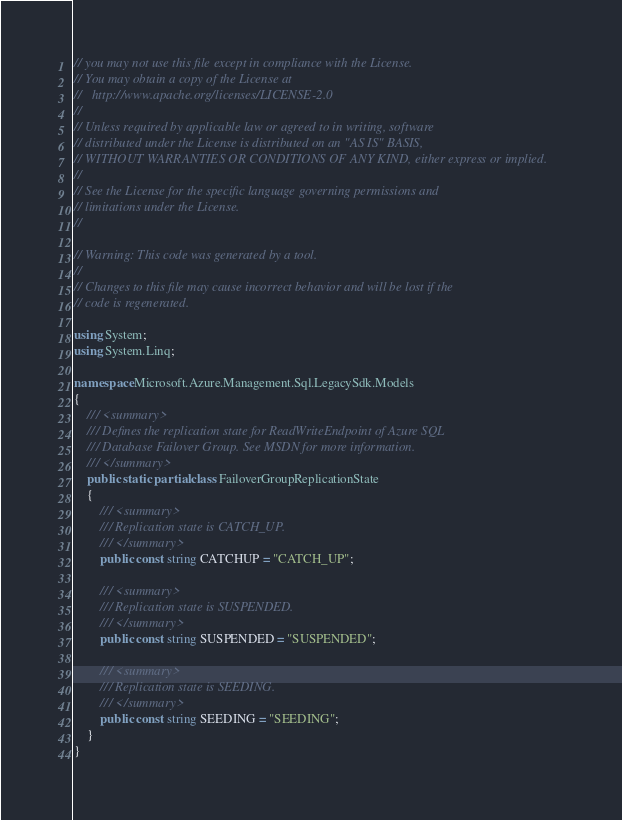<code> <loc_0><loc_0><loc_500><loc_500><_C#_>// you may not use this file except in compliance with the License.
// You may obtain a copy of the License at
//   http://www.apache.org/licenses/LICENSE-2.0
// 
// Unless required by applicable law or agreed to in writing, software
// distributed under the License is distributed on an "AS IS" BASIS,
// WITHOUT WARRANTIES OR CONDITIONS OF ANY KIND, either express or implied.
// 
// See the License for the specific language governing permissions and
// limitations under the License.
// 

// Warning: This code was generated by a tool.
// 
// Changes to this file may cause incorrect behavior and will be lost if the
// code is regenerated.

using System;
using System.Linq;

namespace Microsoft.Azure.Management.Sql.LegacySdk.Models
{
    /// <summary>
    /// Defines the replication state for ReadWriteEndpoint of Azure SQL
    /// Database Failover Group. See MSDN for more information.
    /// </summary>
    public static partial class FailoverGroupReplicationState
    {
        /// <summary>
        /// Replication state is CATCH_UP.
        /// </summary>
        public const string CATCHUP = "CATCH_UP";
        
        /// <summary>
        /// Replication state is SUSPENDED.
        /// </summary>
        public const string SUSPENDED = "SUSPENDED";
        
        /// <summary>
        /// Replication state is SEEDING.
        /// </summary>
        public const string SEEDING = "SEEDING";
    }
}
</code> 